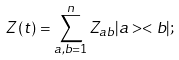Convert formula to latex. <formula><loc_0><loc_0><loc_500><loc_500>Z \left ( t \right ) = \sum _ { a , b = 1 } ^ { n } Z _ { a b } | a > < b | ;</formula> 